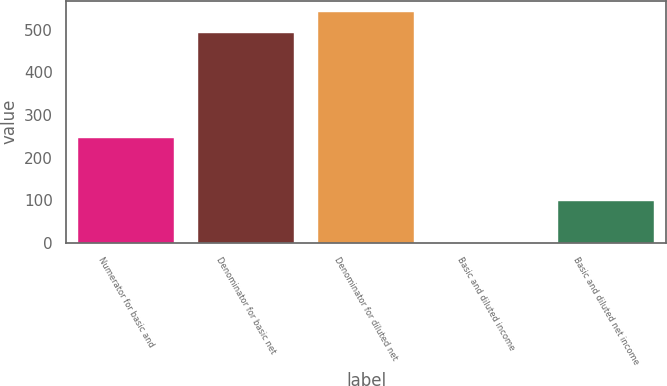Convert chart. <chart><loc_0><loc_0><loc_500><loc_500><bar_chart><fcel>Numerator for basic and<fcel>Denominator for basic net<fcel>Denominator for diluted net<fcel>Basic and diluted income<fcel>Basic and diluted net income<nl><fcel>246.01<fcel>492<fcel>541.19<fcel>0.06<fcel>98.44<nl></chart> 